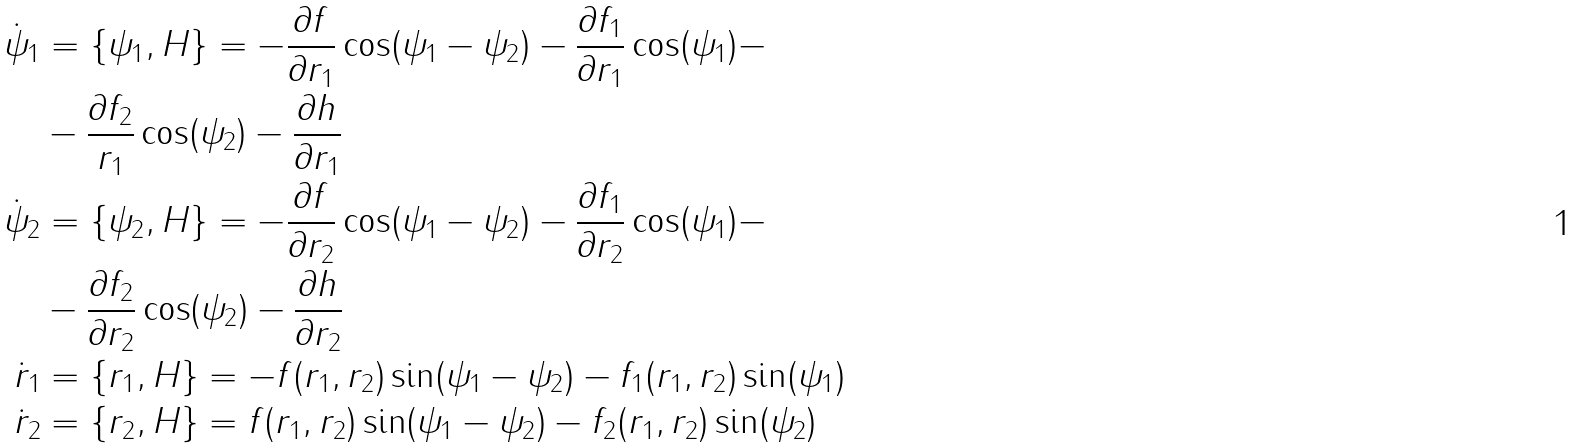Convert formula to latex. <formula><loc_0><loc_0><loc_500><loc_500>\dot { \psi } _ { 1 } & = \{ \psi _ { 1 } , H \} = - \frac { \partial f } { \partial r _ { 1 } } \cos ( \psi _ { 1 } - \psi _ { 2 } ) - \frac { \partial f _ { 1 } } { \partial r _ { 1 } } \cos ( \psi _ { 1 } ) - \\ & - \frac { \partial f _ { 2 } } { r _ { 1 } } \cos ( \psi _ { 2 } ) - \frac { \partial h } { \partial r _ { 1 } } \\ \dot { \psi } _ { 2 } & = \{ \psi _ { 2 } , H \} = - \frac { \partial f } { \partial r _ { 2 } } \cos ( \psi _ { 1 } - \psi _ { 2 } ) - \frac { \partial f _ { 1 } } { \partial r _ { 2 } } \cos ( \psi _ { 1 } ) - \\ & - \frac { \partial f _ { 2 } } { \partial r _ { 2 } } \cos ( \psi _ { 2 } ) - \frac { \partial h } { \partial r _ { 2 } } \\ \dot { r } _ { 1 } & = \{ r _ { 1 } , H \} = - f ( r _ { 1 } , r _ { 2 } ) \sin ( \psi _ { 1 } - \psi _ { 2 } ) - f _ { 1 } ( r _ { 1 } , r _ { 2 } ) \sin ( \psi _ { 1 } ) \\ \dot { r } _ { 2 } & = \{ r _ { 2 } , H \} = f ( r _ { 1 } , r _ { 2 } ) \sin ( \psi _ { 1 } - \psi _ { 2 } ) - f _ { 2 } ( r _ { 1 } , r _ { 2 } ) \sin ( \psi _ { 2 } )</formula> 